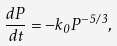Convert formula to latex. <formula><loc_0><loc_0><loc_500><loc_500>\frac { d P } { d t } = - k _ { 0 } P ^ { - 5 / 3 } ,</formula> 